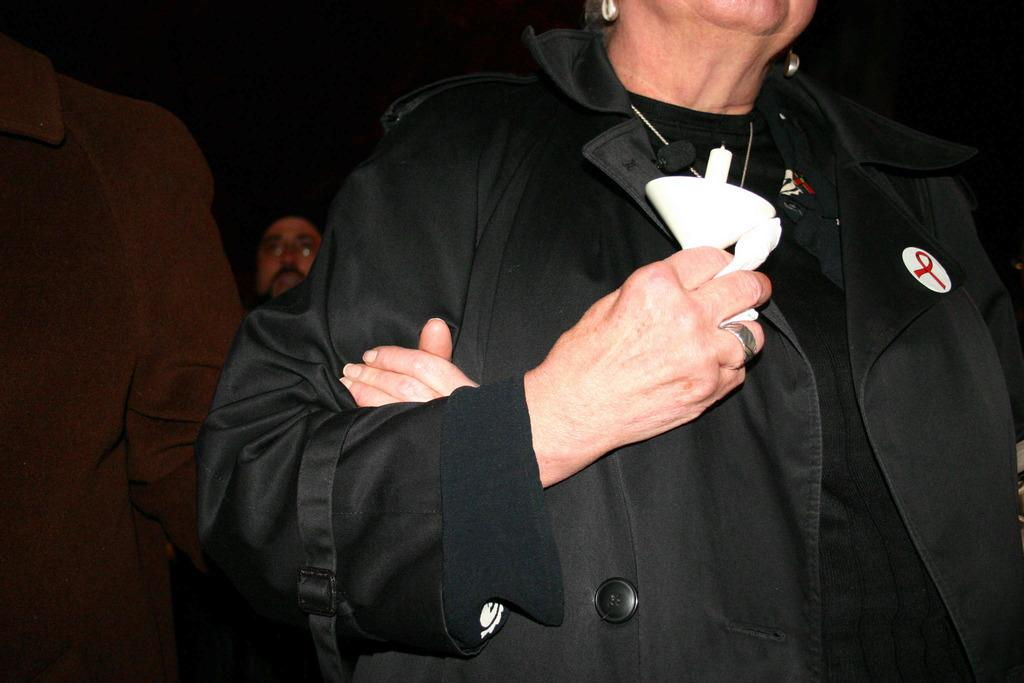How many people are present in the image? There are three people in the image. What colors are the dresses of the people wearing black dresses? The dresses of the people wearing black dresses are black. What color is the dress of the person wearing a brown dress? The dress of the person wearing a brown dress is brown. What is the color of the background in the image? The background of the image is black. Can you recall any memories that the people in the image might be discussing? There is no information about the people's memories or conversations in the image, so it cannot be determined from the image. 